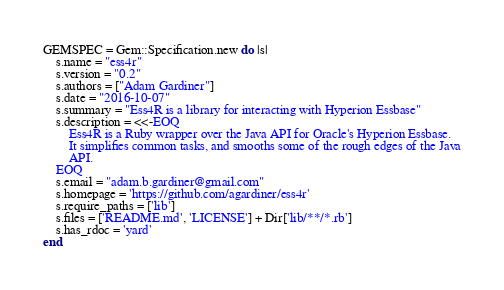Convert code to text. <code><loc_0><loc_0><loc_500><loc_500><_Ruby_>GEMSPEC = Gem::Specification.new do |s|
    s.name = "ess4r"
    s.version = "0.2"
    s.authors = ["Adam Gardiner"]
    s.date = "2016-10-07"
    s.summary = "Ess4R is a library for interacting with Hyperion Essbase"
    s.description = <<-EOQ
        Ess4R is a Ruby wrapper over the Java API for Oracle's Hyperion Essbase.
        It simplifies common tasks, and smooths some of the rough edges of the Java
        API.
    EOQ
    s.email = "adam.b.gardiner@gmail.com"
    s.homepage = 'https://github.com/agardiner/ess4r'
    s.require_paths = ['lib']
    s.files = ['README.md', 'LICENSE'] + Dir['lib/**/*.rb']
    s.has_rdoc = 'yard'
end
</code> 